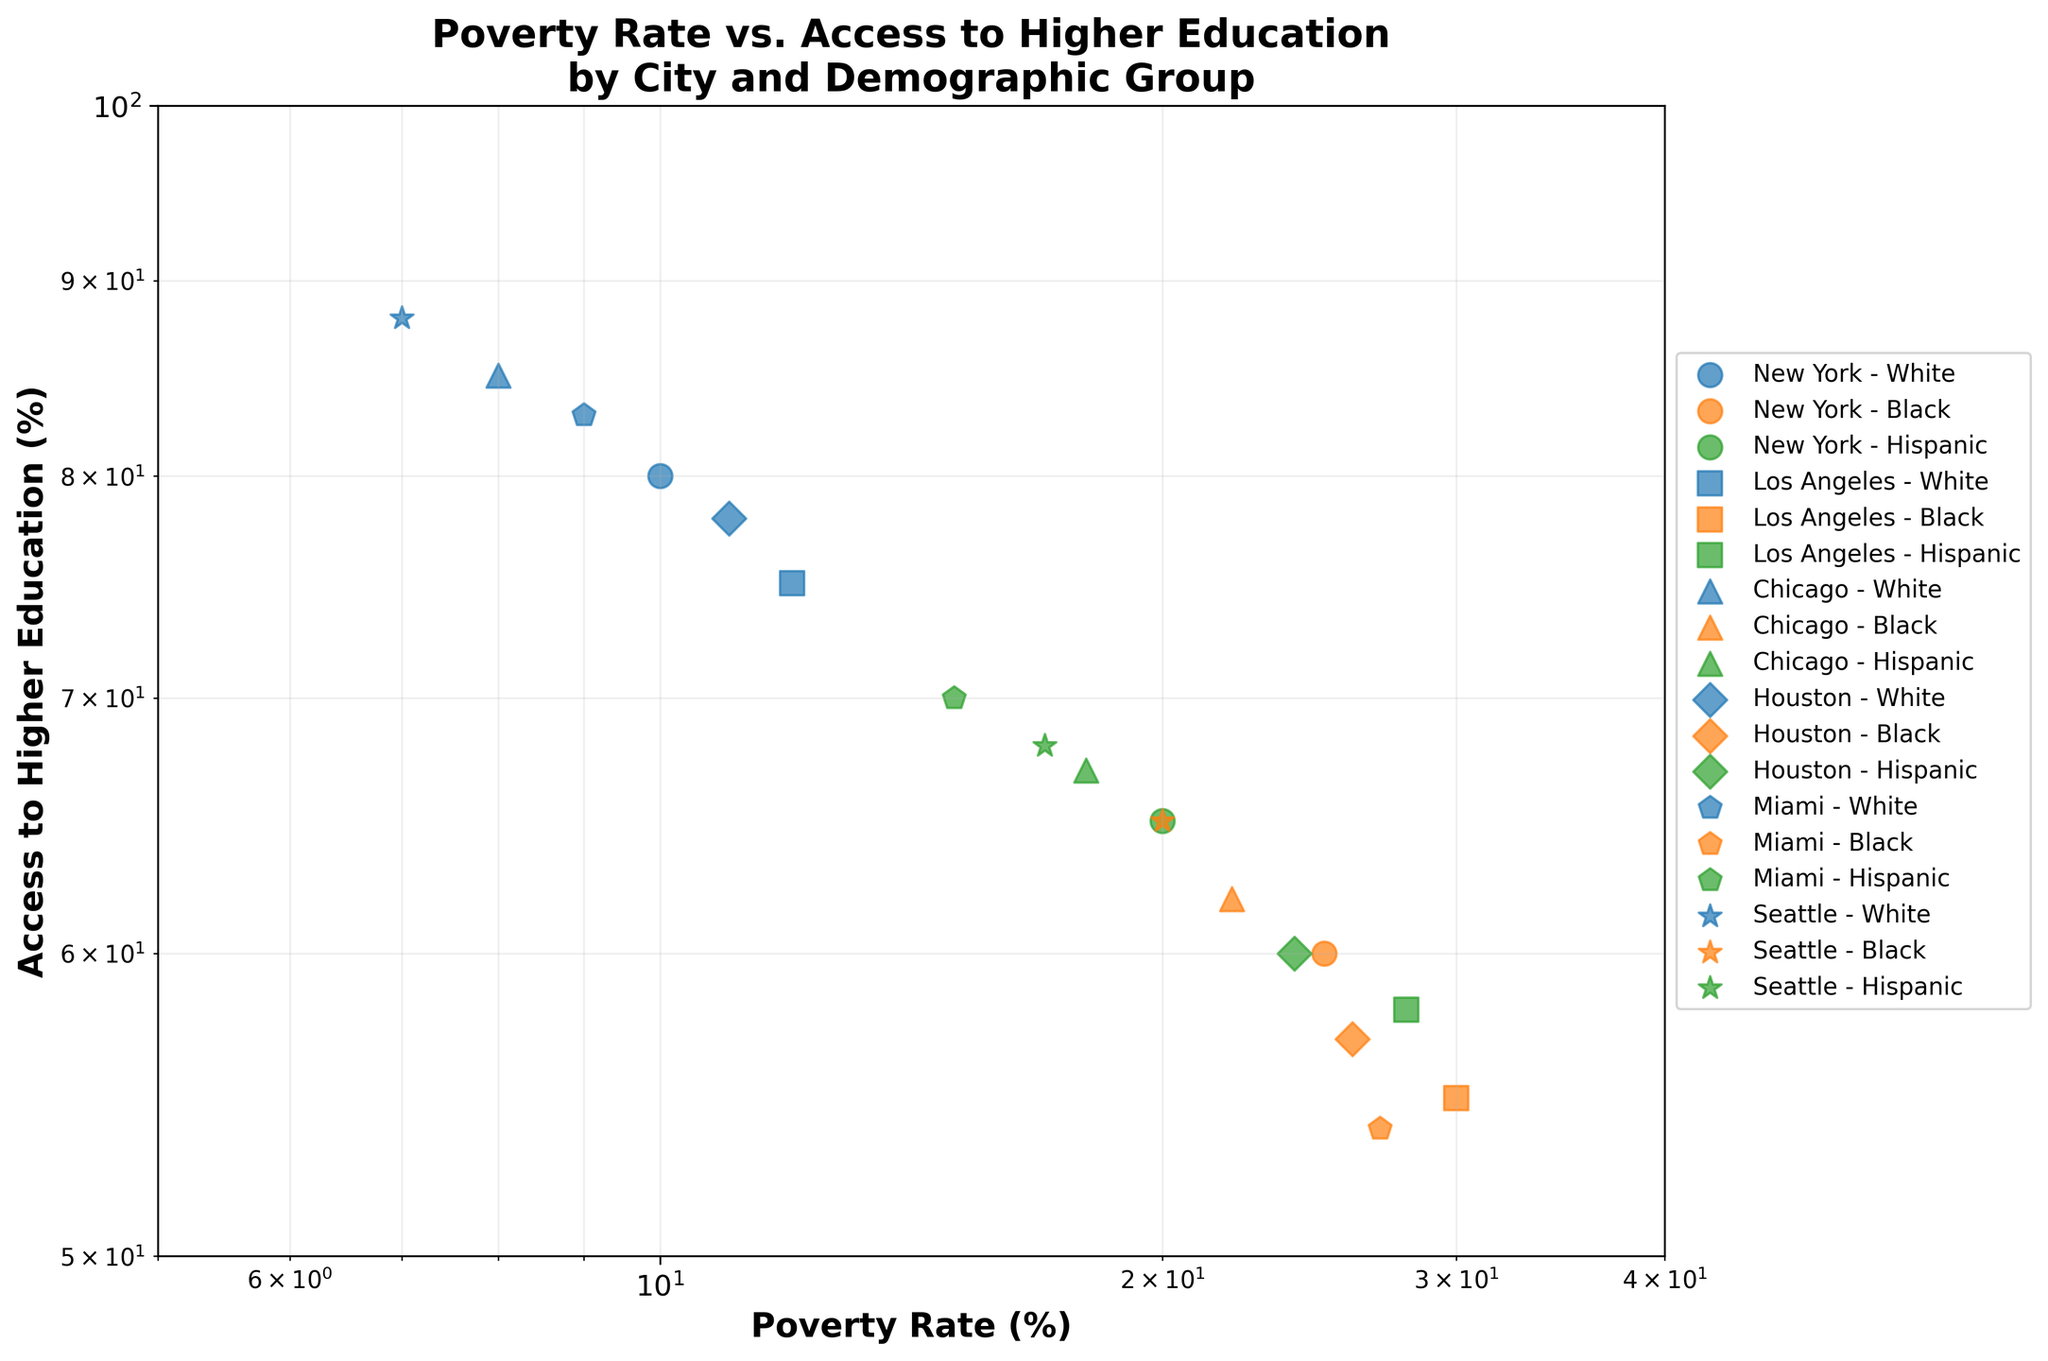What is the title of the figure? The title is usually found at the top of the figure; look for a bold and larger text that summarizes the content.
Answer: Poverty Rate vs. Access to Higher Education by City and Demographic Group How many demographic groups are represented in the figure? The legend of the figure shows labels corresponding to the demographic groups, indicated by different colors. Count these unique labels.
Answer: 3 Which city-demographic group has the highest access to higher education? Look for the point with the highest y-value on the access to higher education axis and read its label to identify the city-demographic group.
Answer: Seattle - White Compare the poverty rate of Black people in New York and Los Angeles. Which city has a higher rate? Locate the points labeled "New York - Black" and "Los Angeles - Black" and compare their x-values, which represent the poverty rates.
Answer: Los Angeles What is the range of the poverty rate represented in the plot? The x-axis represents logarithmic values; find the smallest and largest values for the poverty rate. The plot indicates these limits.
Answer: 7% to 30% Which demographic group has the least access to higher education in Miami? Find the points labeled "Miami" and see which color (demographic group) corresponds to the lowest y-value on the access to higher education axis.
Answer: Black Calculate the average access to higher education for Hispanic groups across all cities. Identify the y-values for all points labeled Hispanic, sum them up, and divide by the number of these points.
Answer: (65 + 58 + 67 + 60 + 70 + 68)/6 = 64.67 For the city with the highest access to higher education among White demographics, what is the corresponding poverty rate? Locate the highest y-value for White demographics and identify its corresponding x-value (poverty rate) and city.
Answer: Seattle, 7% Is there a general trend between poverty rate and access to higher education for Black demographic groups? Observe the general direction of Black demographics' points across the plot. Check if higher poverty rates tend to correspond to lower access to higher education.
Answer: Yes, higher poverty rates generally correspond to lower access to higher education Which demographic group has the lowest access to higher education across all cities? Find the point with the lowest y-value regardless of city, and check its color to determine the demographic group.
Answer: Black 